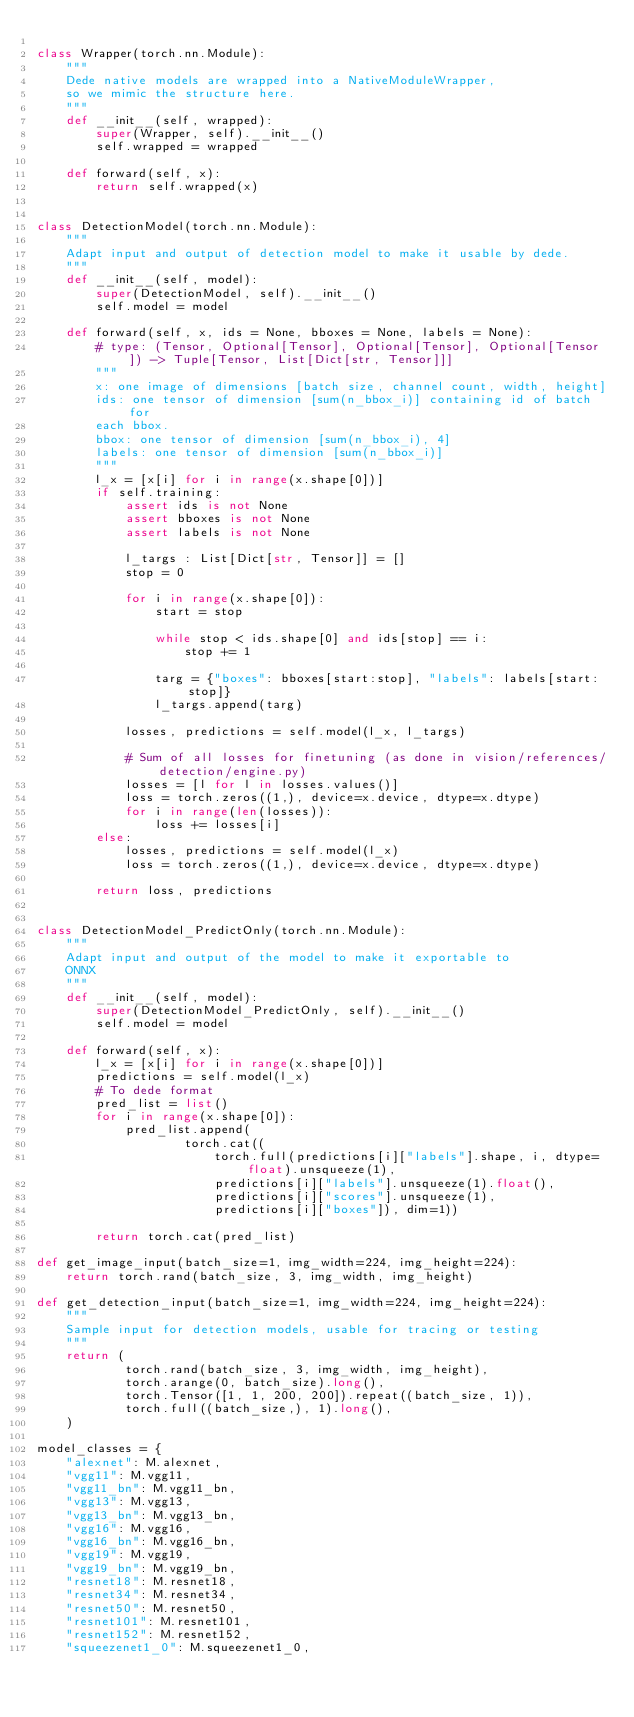<code> <loc_0><loc_0><loc_500><loc_500><_Python_>
class Wrapper(torch.nn.Module):
    """
    Dede native models are wrapped into a NativeModuleWrapper,
    so we mimic the structure here.
    """
    def __init__(self, wrapped):
        super(Wrapper, self).__init__()
        self.wrapped = wrapped

    def forward(self, x):
        return self.wrapped(x)


class DetectionModel(torch.nn.Module):
    """
    Adapt input and output of detection model to make it usable by dede.
    """
    def __init__(self, model):
        super(DetectionModel, self).__init__()
        self.model = model

    def forward(self, x, ids = None, bboxes = None, labels = None):
        # type: (Tensor, Optional[Tensor], Optional[Tensor], Optional[Tensor]) -> Tuple[Tensor, List[Dict[str, Tensor]]]
        """
        x: one image of dimensions [batch size, channel count, width, height]
        ids: one tensor of dimension [sum(n_bbox_i)] containing id of batch for
        each bbox.
        bbox: one tensor of dimension [sum(n_bbox_i), 4]
        labels: one tensor of dimension [sum(n_bbox_i)]
        """
        l_x = [x[i] for i in range(x.shape[0])]
        if self.training:
            assert ids is not None
            assert bboxes is not None
            assert labels is not None

            l_targs : List[Dict[str, Tensor]] = []
            stop = 0

            for i in range(x.shape[0]):
                start = stop

                while stop < ids.shape[0] and ids[stop] == i:
                    stop += 1

                targ = {"boxes": bboxes[start:stop], "labels": labels[start:stop]}
                l_targs.append(targ)

            losses, predictions = self.model(l_x, l_targs)

            # Sum of all losses for finetuning (as done in vision/references/detection/engine.py)
            losses = [l for l in losses.values()]
            loss = torch.zeros((1,), device=x.device, dtype=x.dtype)
            for i in range(len(losses)):
                loss += losses[i]
        else:
            losses, predictions = self.model(l_x)
            loss = torch.zeros((1,), device=x.device, dtype=x.dtype)

        return loss, predictions


class DetectionModel_PredictOnly(torch.nn.Module):
    """
    Adapt input and output of the model to make it exportable to
    ONNX
    """
    def __init__(self, model):
        super(DetectionModel_PredictOnly, self).__init__()
        self.model = model

    def forward(self, x):
        l_x = [x[i] for i in range(x.shape[0])]
        predictions = self.model(l_x)
        # To dede format
        pred_list = list()
        for i in range(x.shape[0]):
            pred_list.append(
                    torch.cat((
                        torch.full(predictions[i]["labels"].shape, i, dtype=float).unsqueeze(1),
                        predictions[i]["labels"].unsqueeze(1).float(),
                        predictions[i]["scores"].unsqueeze(1),
                        predictions[i]["boxes"]), dim=1))

        return torch.cat(pred_list)

def get_image_input(batch_size=1, img_width=224, img_height=224):
    return torch.rand(batch_size, 3, img_width, img_height)

def get_detection_input(batch_size=1, img_width=224, img_height=224):
    """
    Sample input for detection models, usable for tracing or testing
    """
    return (
            torch.rand(batch_size, 3, img_width, img_height),
            torch.arange(0, batch_size).long(),
            torch.Tensor([1, 1, 200, 200]).repeat((batch_size, 1)),
            torch.full((batch_size,), 1).long(),
    )

model_classes = {
    "alexnet": M.alexnet,
    "vgg11": M.vgg11,
    "vgg11_bn": M.vgg11_bn,
    "vgg13": M.vgg13,
    "vgg13_bn": M.vgg13_bn,
    "vgg16": M.vgg16,
    "vgg16_bn": M.vgg16_bn,
    "vgg19": M.vgg19,
    "vgg19_bn": M.vgg19_bn,
    "resnet18": M.resnet18,
    "resnet34": M.resnet34,
    "resnet50": M.resnet50,
    "resnet101": M.resnet101,
    "resnet152": M.resnet152,
    "squeezenet1_0": M.squeezenet1_0,</code> 